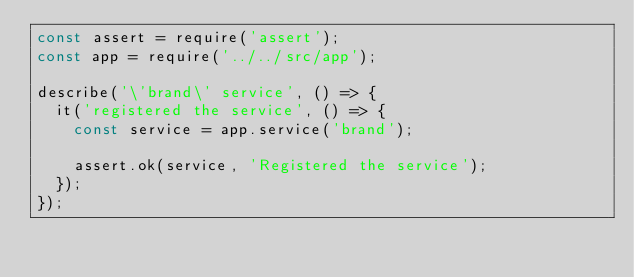<code> <loc_0><loc_0><loc_500><loc_500><_JavaScript_>const assert = require('assert');
const app = require('../../src/app');

describe('\'brand\' service', () => {
  it('registered the service', () => {
    const service = app.service('brand');

    assert.ok(service, 'Registered the service');
  });
});
</code> 